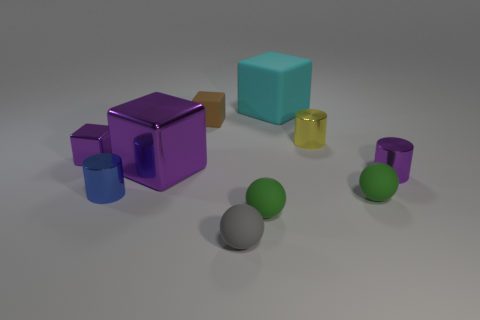Subtract all small purple blocks. How many blocks are left? 3 Subtract all blue cylinders. Subtract all yellow blocks. How many cylinders are left? 2 Subtract all green spheres. How many gray cylinders are left? 0 Subtract all cyan rubber things. Subtract all big cyan metal things. How many objects are left? 9 Add 5 small purple metal objects. How many small purple metal objects are left? 7 Add 1 big green objects. How many big green objects exist? 1 Subtract all green balls. How many balls are left? 1 Subtract 1 blue cylinders. How many objects are left? 9 Subtract all cylinders. How many objects are left? 7 Subtract 3 cubes. How many cubes are left? 1 